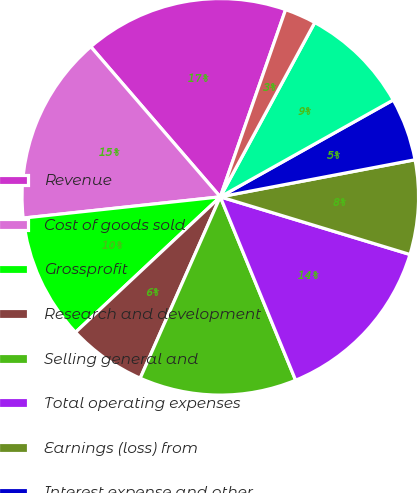Convert chart. <chart><loc_0><loc_0><loc_500><loc_500><pie_chart><fcel>Revenue<fcel>Cost of goods sold<fcel>Grossprofit<fcel>Research and development<fcel>Selling general and<fcel>Total operating expenses<fcel>Earnings (loss) from<fcel>Interest expense and other<fcel>Unnamed: 8<fcel>Income tax provision<nl><fcel>16.67%<fcel>15.38%<fcel>10.26%<fcel>6.41%<fcel>12.82%<fcel>14.1%<fcel>7.69%<fcel>5.13%<fcel>8.97%<fcel>2.56%<nl></chart> 